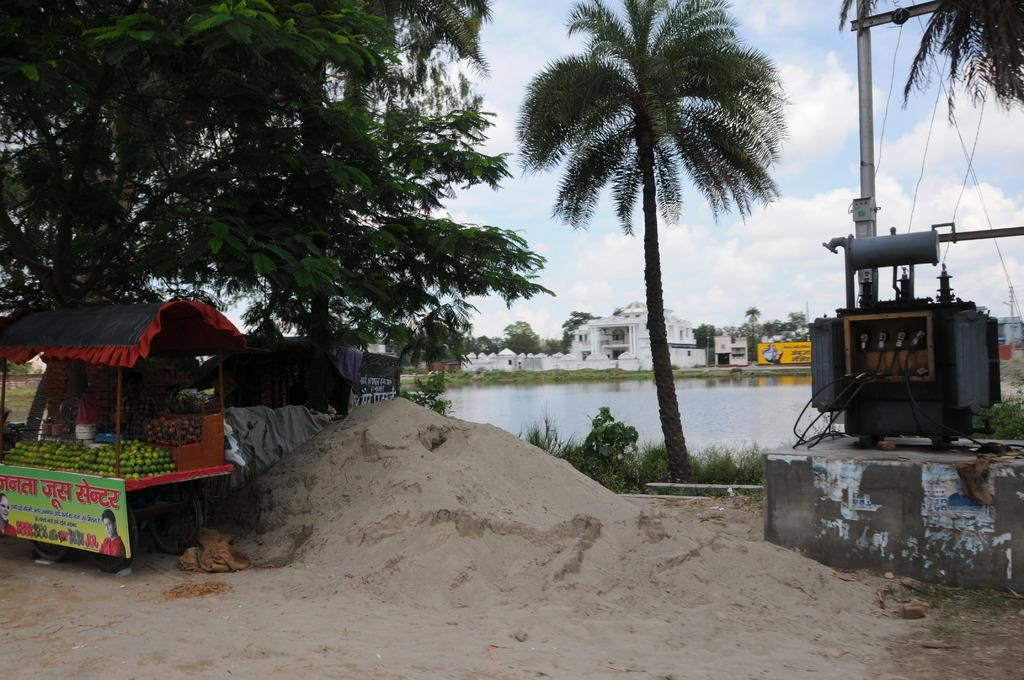What body of water is present in the image? There is a small lake in the image. What structures are located near the lake? There are buildings beside the lake. What type of vegetation can be seen in the image? There are trees in the image. What mode of transportation is visible in the image? There is a vehicle in the image. What is placed on the vehicle? Fruits are placed on the vehicle. Is there a hose being used to extinguish a fire in the image? No, there is no fire or hose present in the image. How does the wind affect the trees in the image? There is no mention of wind in the image, so we cannot determine its effect on the trees. 